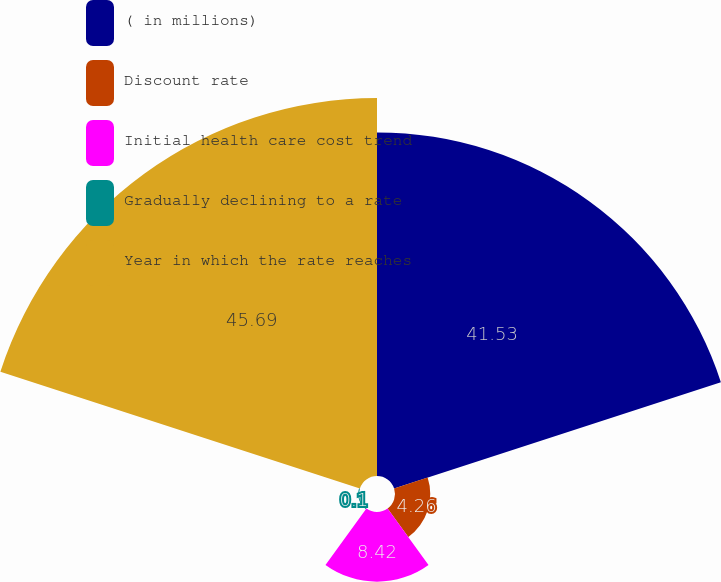Convert chart to OTSL. <chart><loc_0><loc_0><loc_500><loc_500><pie_chart><fcel>( in millions)<fcel>Discount rate<fcel>Initial health care cost trend<fcel>Gradually declining to a rate<fcel>Year in which the rate reaches<nl><fcel>41.53%<fcel>4.26%<fcel>8.42%<fcel>0.1%<fcel>45.69%<nl></chart> 